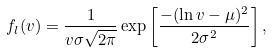<formula> <loc_0><loc_0><loc_500><loc_500>f _ { l } ( v ) = \frac { 1 } { v \sigma \sqrt { 2 \pi } } \exp \left [ { \frac { - ( \ln { v } - \mu ) ^ { 2 } } { 2 \sigma ^ { 2 } } } \right ] ,</formula> 